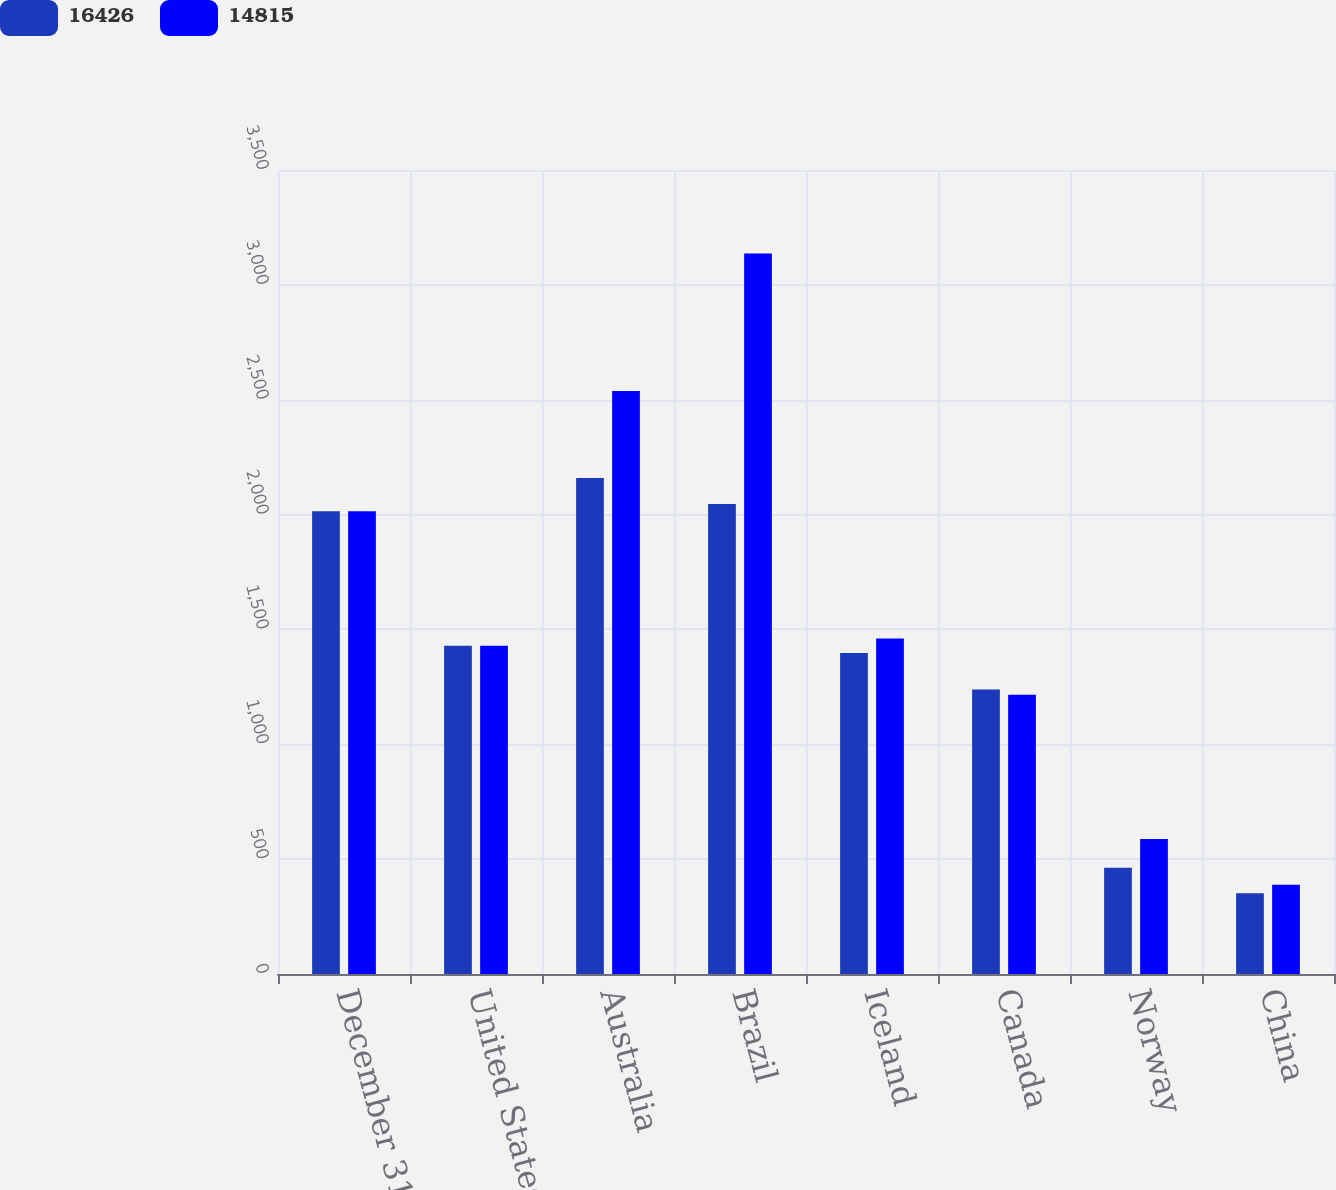Convert chart to OTSL. <chart><loc_0><loc_0><loc_500><loc_500><stacked_bar_chart><ecel><fcel>December 31<fcel>United States<fcel>Australia<fcel>Brazil<fcel>Iceland<fcel>Canada<fcel>Norway<fcel>China<nl><fcel>16426<fcel>2015<fcel>1428.5<fcel>2159<fcel>2046<fcel>1397<fcel>1238<fcel>463<fcel>352<nl><fcel>14815<fcel>2014<fcel>1428.5<fcel>2538<fcel>3137<fcel>1460<fcel>1216<fcel>588<fcel>389<nl></chart> 